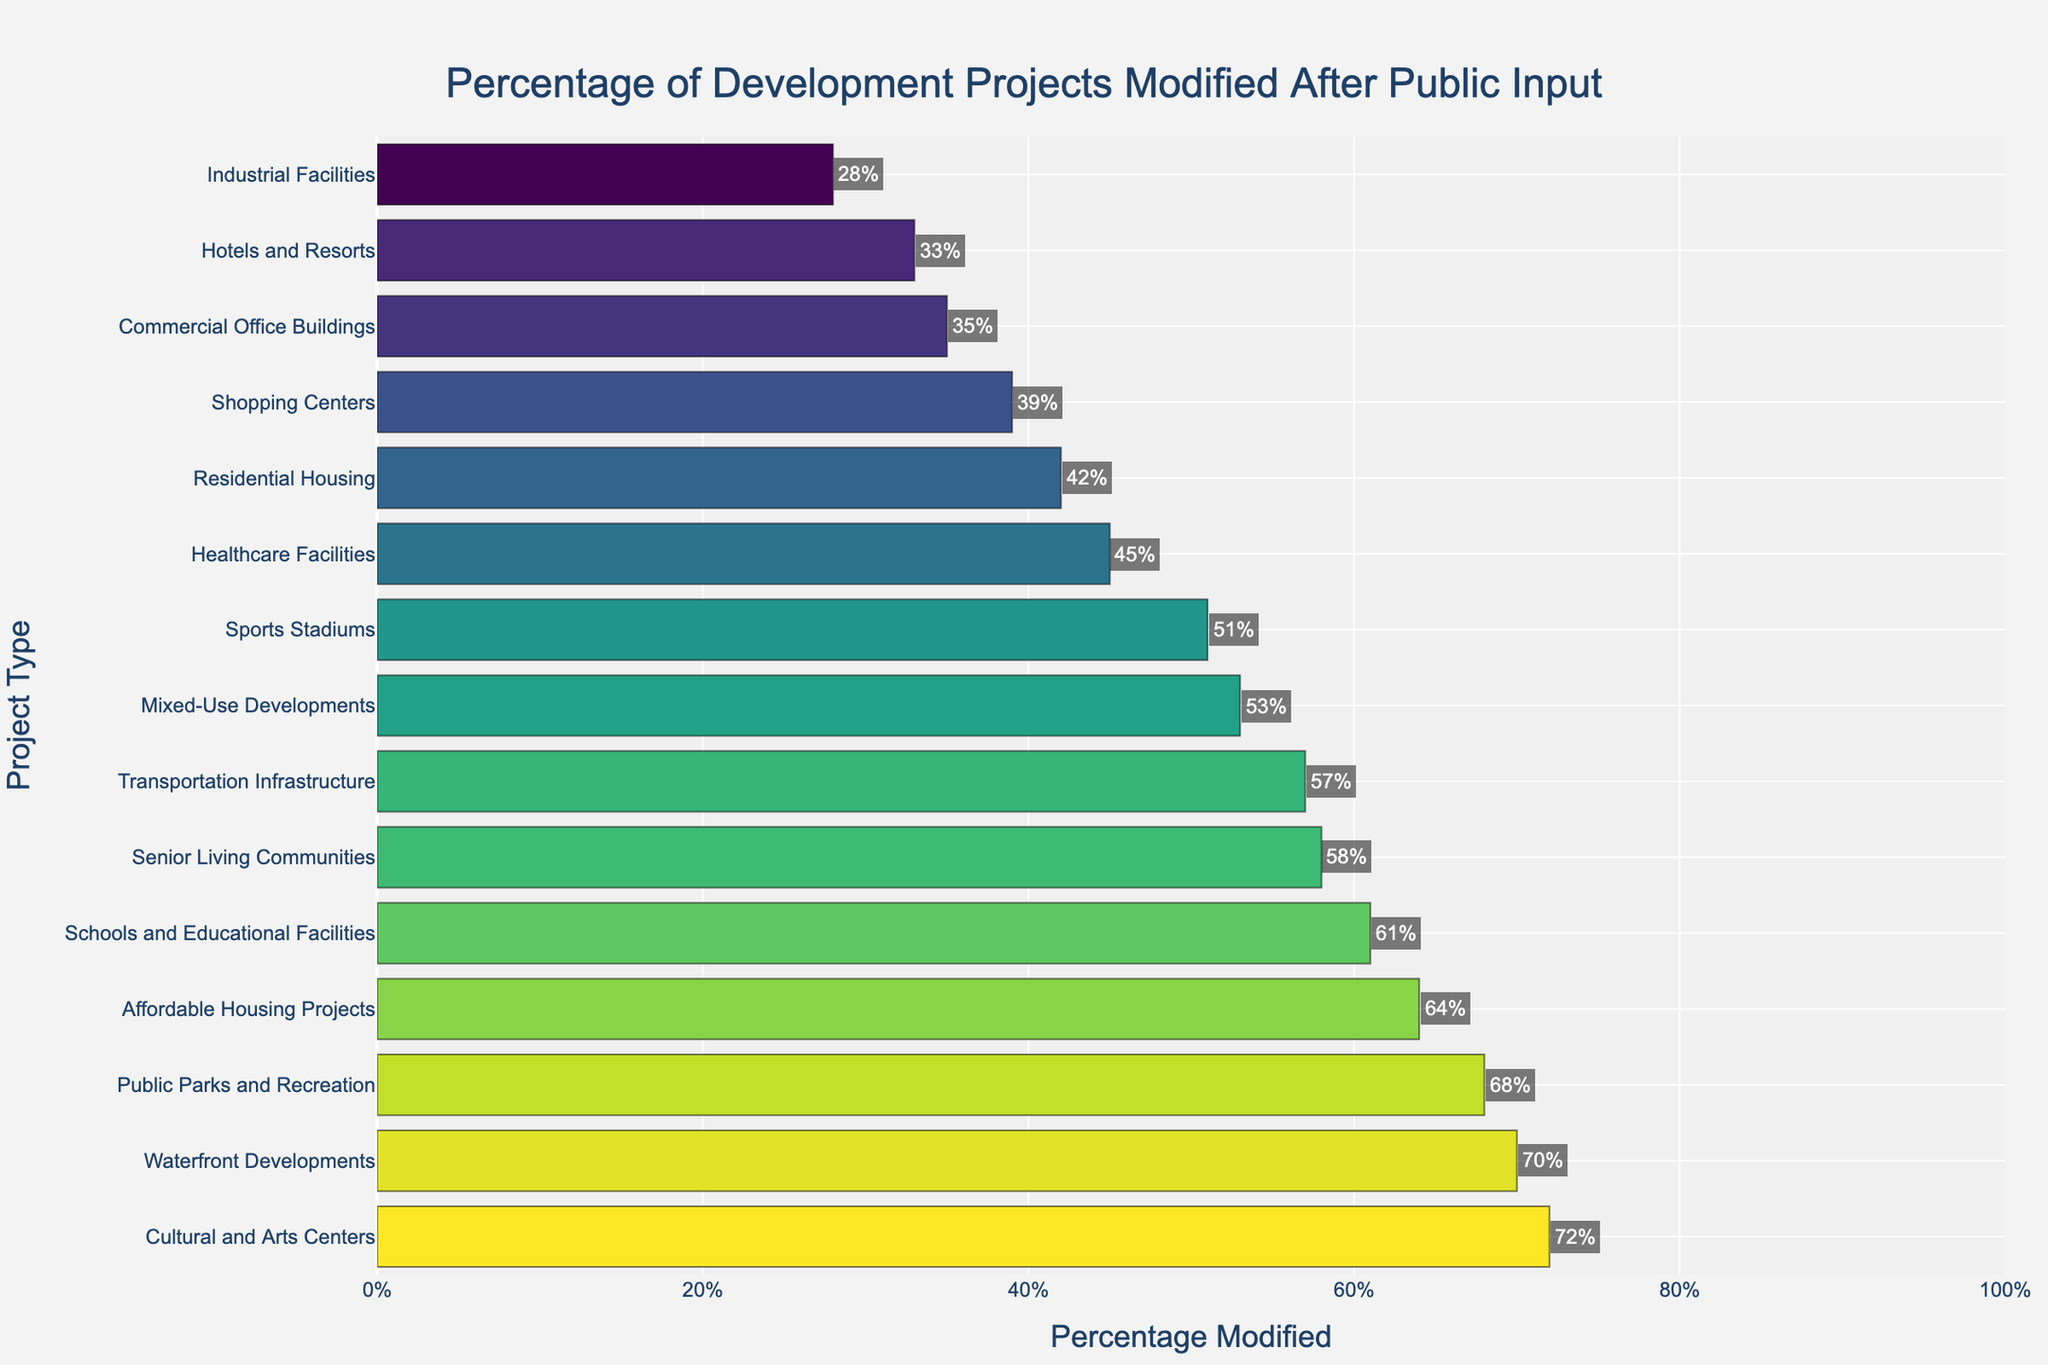Which project type has the highest percentage of modifications after public input? The project type with the highest value on the horizontal bar chart represents the one with the highest percentage of modifications. This bar is both longest and located at the top of the sorted chart.
Answer: Cultural and Arts Centers Which project type has the lowest percentage of modifications after public input? The project type with the lowest value is at the bottom of the bar chart. This bar is the shortest.
Answer: Industrial Facilities What is the average percentage of projects modified after public input across all project types? Sum all percentages and divide by the number of project types: (42 + 35 + 53 + 68 + 39 + 28 + 61 + 45 + 57 + 72 + 51 + 64 + 58 + 33 + 70) / 15 = 56%.
Answer: 56% What is the difference in percentage modifications between Schools and Educational Facilities and Industrial Facilities? Subtract the percentage of Industrial Facilities from that of Schools and Educational Facilities: 61% - 28% = 33%.
Answer: 33% How many project types have a modification percentage of 50% or more? Count the number of project types where the percentage is equal to or greater than 50%. They include: Mixed-Use Developments (53%), Public Parks and Recreation (68%), Schools and Educational Facilities (61%), Transportation Infrastructure (57%), Cultural and Arts Centers (72%), Sports Stadiums (51%), Affordable Housing Projects (64%), Senior Living Communities (58%), and Waterfront Developments (70%). There are 9 project types.
Answer: 9 Compare the percentage of modifications of Residential Housing and Shopping Centers. Which one has a higher percentage? Compare the length of bars or the percentages: Residential Housing (42%) versus Shopping Centers (39%). Residential Housing has a higher percentage.
Answer: Residential Housing Which three project types have modification percentages closest to the average percentage of 56%? Identify the three project types whose percentages are nearest to 56%: Schools and Educational Facilities (61%), Transportation Infrastructure (57%), and Sports Stadiums (51%).
Answer: Schools and Educational Facilities, Transportation Infrastructure, and Sports Stadiums Are healthcare facilities more likely to be modified after public input than hotels and resorts? Compare the bar lengths or percentages: Healthcare Facilities (45%) versus Hotels and Resorts (33%). Healthcare Facilities have a higher percentage of modifications.
Answer: Yes What is the sum of modification percentages for Public Parks and Recreation, Transportation Infrastructure, and Waterfront Developments? Add the percentages for the three project types: 68% (Public Parks and Recreation) + 57% (Transportation Infrastructure) + 70% (Waterfront Developments) = 195%.
Answer: 195% Which project type has the second highest percentage of modifications after public input? The second bar from the top in the sorted bar chart should have the second highest value. For this, it is Waterfront Developments at 70%.
Answer: Waterfront Developments 